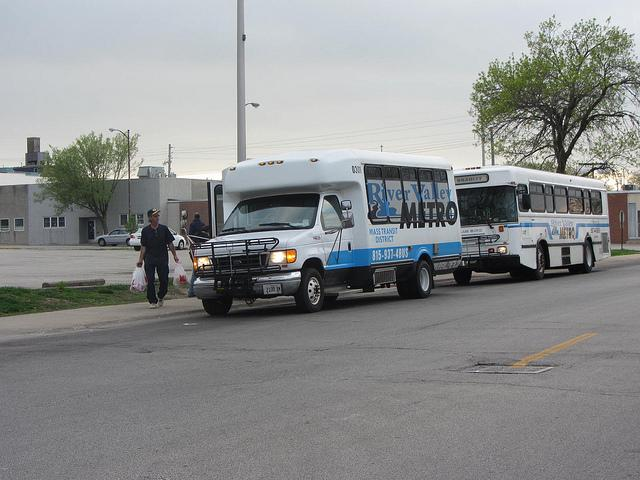What did the man on the sidewalk most likely just do?

Choices:
A) shop
B) shower
C) steal
D) exercise shop 